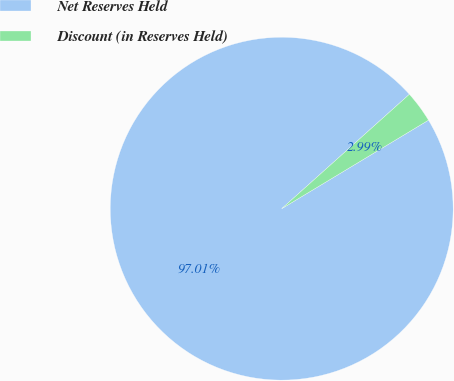<chart> <loc_0><loc_0><loc_500><loc_500><pie_chart><fcel>Net Reserves Held<fcel>Discount (in Reserves Held)<nl><fcel>97.01%<fcel>2.99%<nl></chart> 